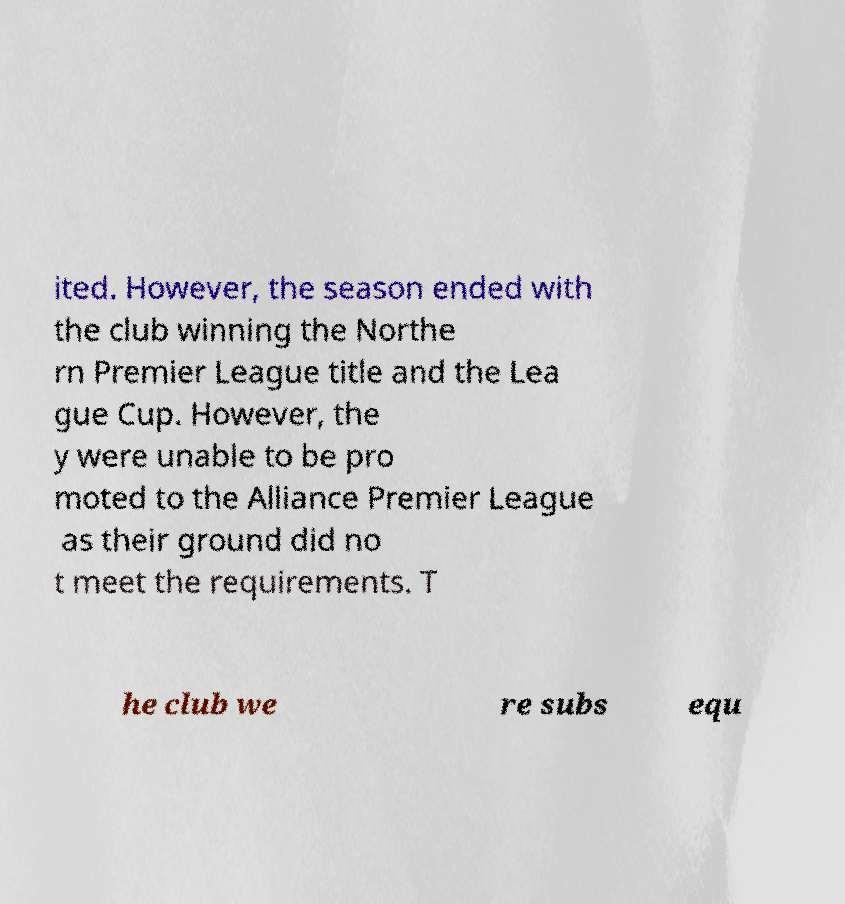I need the written content from this picture converted into text. Can you do that? ited. However, the season ended with the club winning the Northe rn Premier League title and the Lea gue Cup. However, the y were unable to be pro moted to the Alliance Premier League as their ground did no t meet the requirements. T he club we re subs equ 